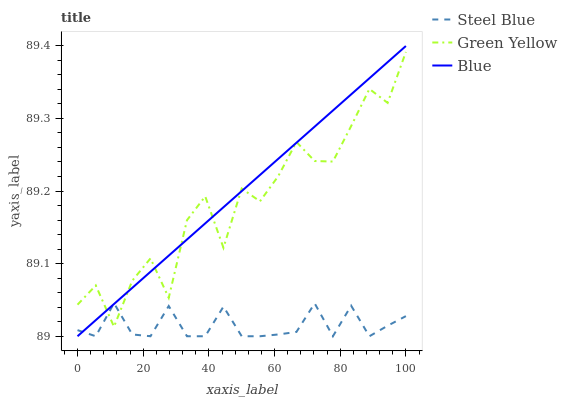Does Green Yellow have the minimum area under the curve?
Answer yes or no. No. Does Green Yellow have the maximum area under the curve?
Answer yes or no. No. Is Steel Blue the smoothest?
Answer yes or no. No. Is Steel Blue the roughest?
Answer yes or no. No. Does Green Yellow have the lowest value?
Answer yes or no. No. Does Green Yellow have the highest value?
Answer yes or no. No. 